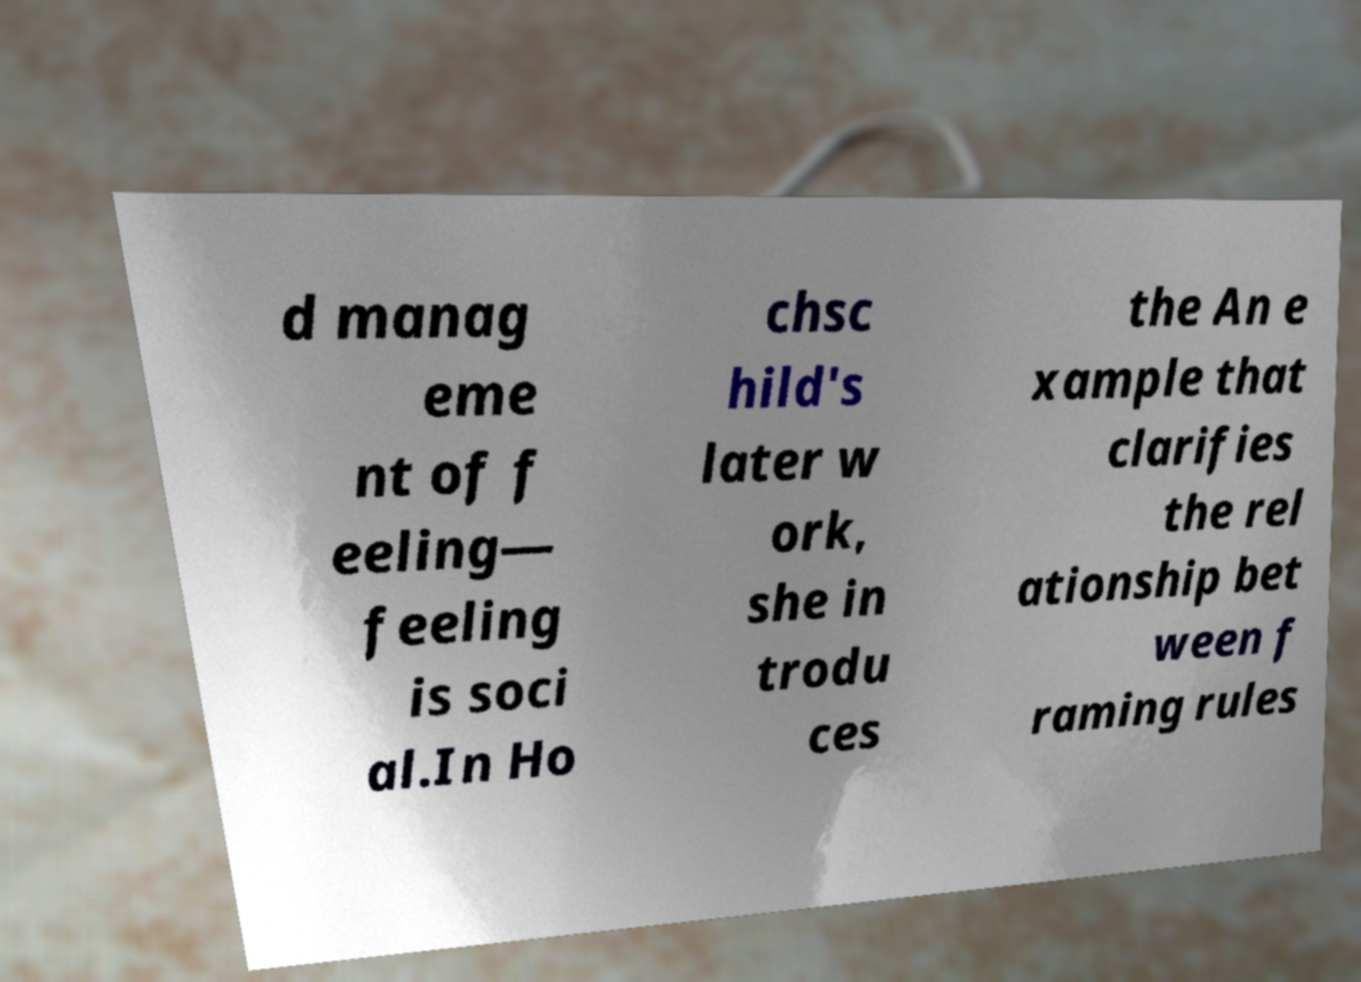Can you read and provide the text displayed in the image?This photo seems to have some interesting text. Can you extract and type it out for me? d manag eme nt of f eeling— feeling is soci al.In Ho chsc hild's later w ork, she in trodu ces the An e xample that clarifies the rel ationship bet ween f raming rules 